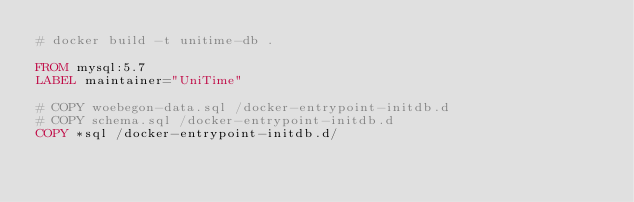Convert code to text. <code><loc_0><loc_0><loc_500><loc_500><_Dockerfile_># docker build -t unitime-db . 

FROM mysql:5.7
LABEL maintainer="UniTime"

# COPY woebegon-data.sql /docker-entrypoint-initdb.d
# COPY schema.sql /docker-entrypoint-initdb.d
COPY *sql /docker-entrypoint-initdb.d/

</code> 